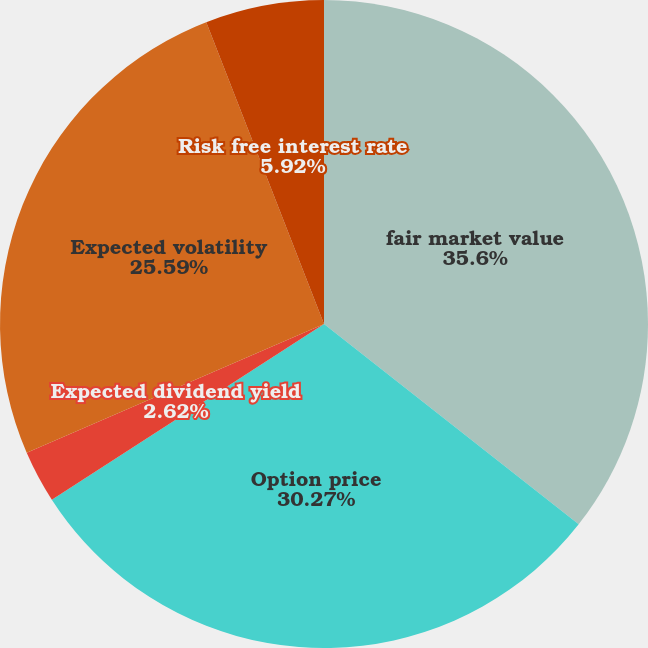Convert chart to OTSL. <chart><loc_0><loc_0><loc_500><loc_500><pie_chart><fcel>fair market value<fcel>Option price<fcel>Expected dividend yield<fcel>Expected volatility<fcel>Risk free interest rate<nl><fcel>35.61%<fcel>30.27%<fcel>2.62%<fcel>25.59%<fcel>5.92%<nl></chart> 